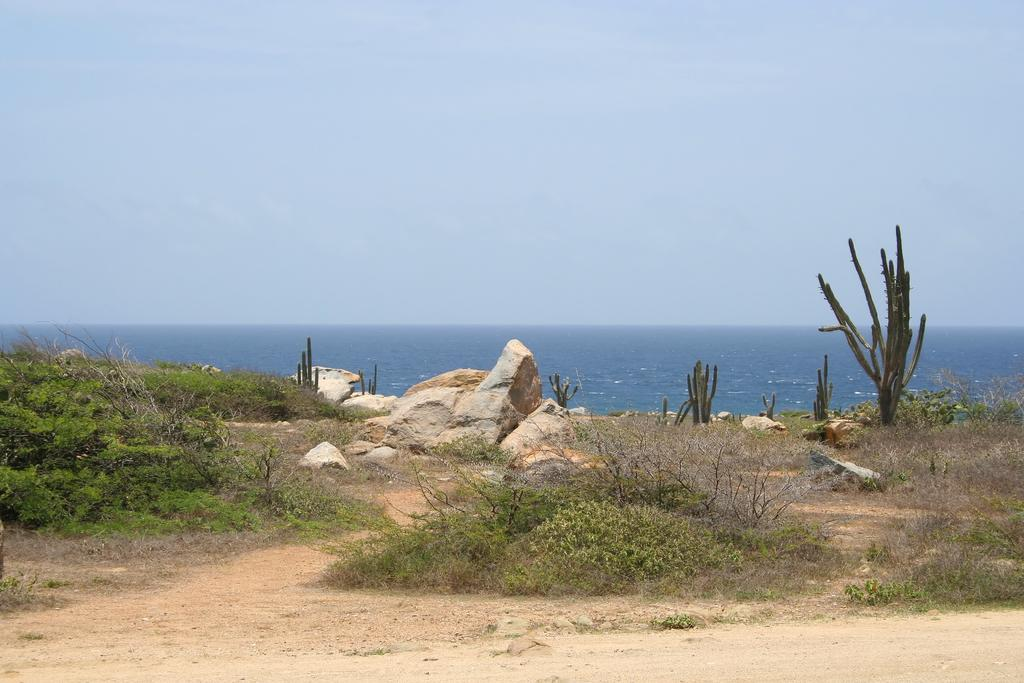What type of natural elements can be seen on the ground in the image? There are rocks on the ground in the image. What other natural elements can be seen in the image? There are plants visible in the image. What can be seen in the distance in the image? There is an ocean in the background of the image. What is visible above the ocean in the image? The sky is visible in the background of the image. Where is the kettle located in the image? There is no kettle present in the image. What type of mailbox can be seen near the plants in the image? There is no mailbox present in the image. 